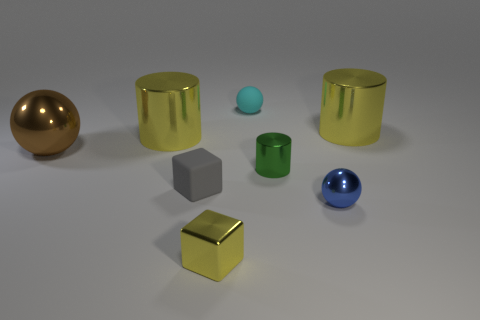Add 2 shiny things. How many objects exist? 10 Subtract all spheres. How many objects are left? 5 Add 6 small yellow objects. How many small yellow objects exist? 7 Subtract 1 cyan balls. How many objects are left? 7 Subtract all large brown rubber objects. Subtract all brown shiny balls. How many objects are left? 7 Add 7 cyan spheres. How many cyan spheres are left? 8 